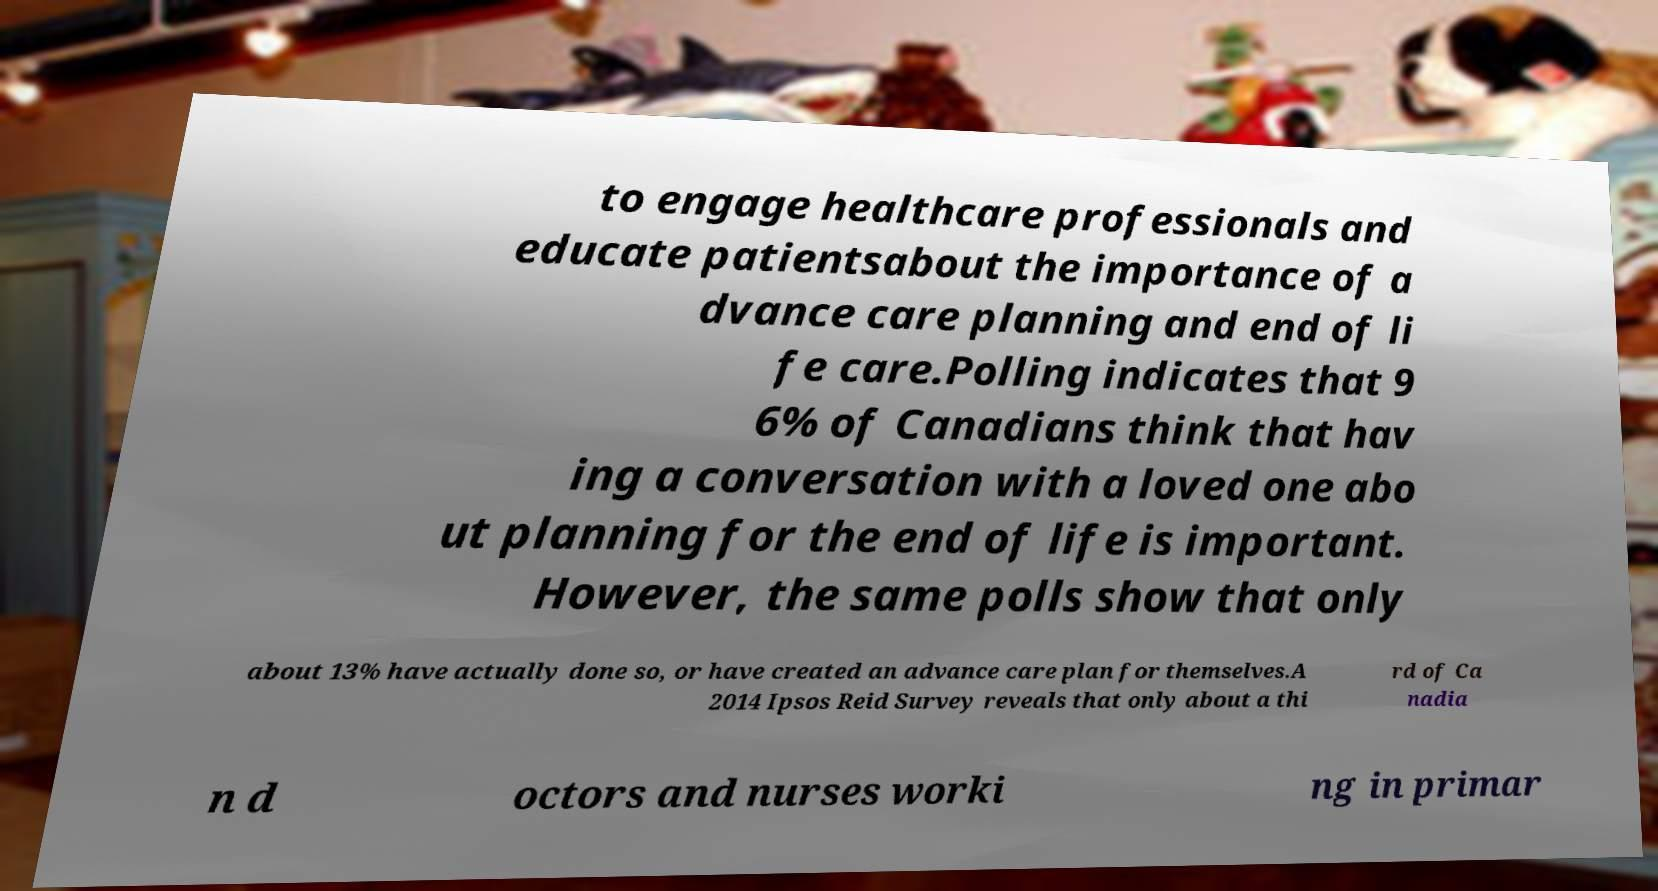Please read and relay the text visible in this image. What does it say? to engage healthcare professionals and educate patientsabout the importance of a dvance care planning and end of li fe care.Polling indicates that 9 6% of Canadians think that hav ing a conversation with a loved one abo ut planning for the end of life is important. However, the same polls show that only about 13% have actually done so, or have created an advance care plan for themselves.A 2014 Ipsos Reid Survey reveals that only about a thi rd of Ca nadia n d octors and nurses worki ng in primar 